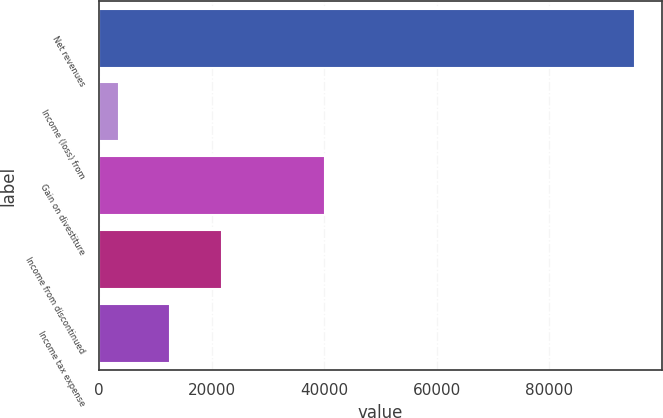<chart> <loc_0><loc_0><loc_500><loc_500><bar_chart><fcel>Net revenues<fcel>Income (loss) from<fcel>Gain on divestiture<fcel>Income from discontinued<fcel>Income tax expense<nl><fcel>95226<fcel>3472<fcel>40173.6<fcel>21822.8<fcel>12647.4<nl></chart> 